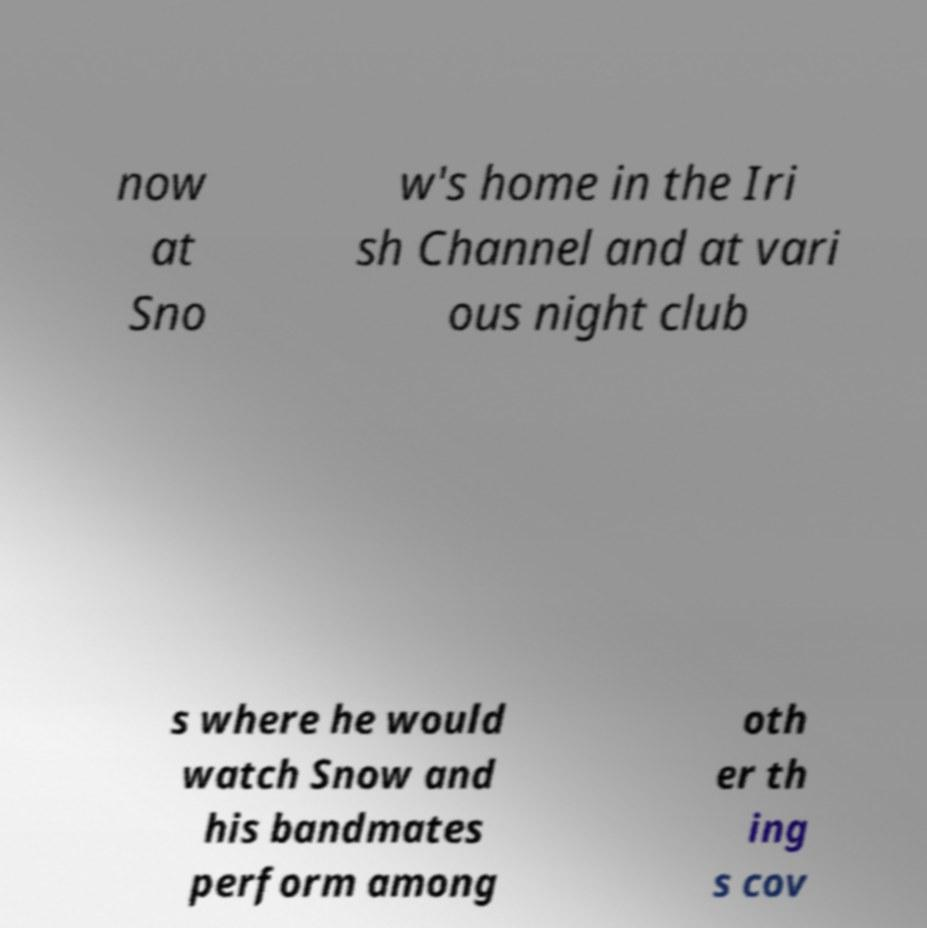Could you assist in decoding the text presented in this image and type it out clearly? now at Sno w's home in the Iri sh Channel and at vari ous night club s where he would watch Snow and his bandmates perform among oth er th ing s cov 